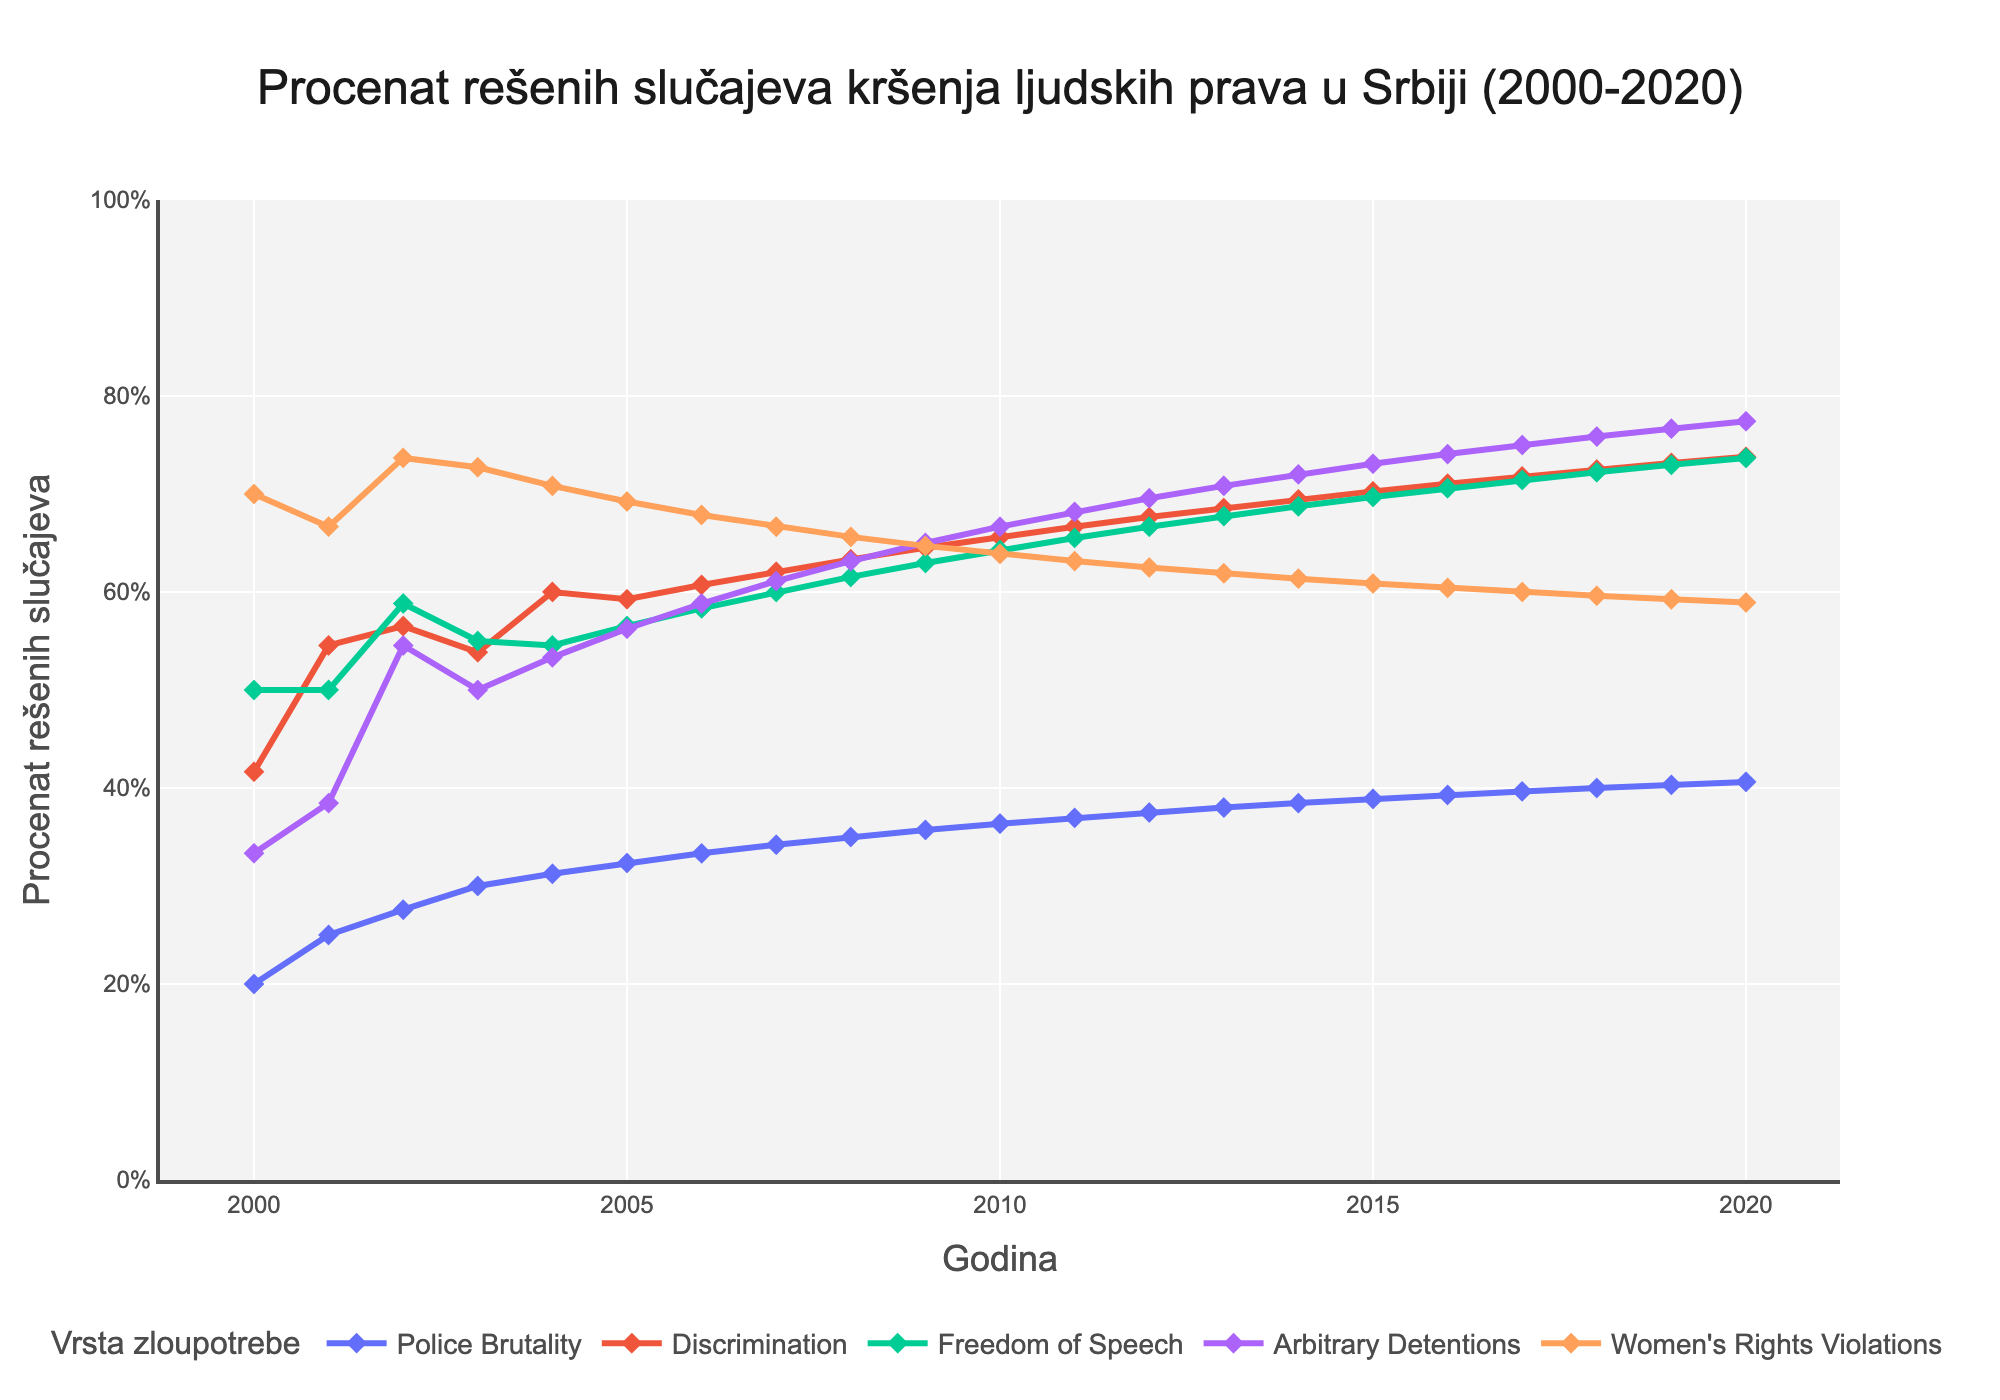What's the title of the figure? The title is displayed at the top of the figure. It summarizes the main subject of the plot, which is about the resolved cases of human rights abuses in Serbia over the given time period.
Answer: Procenat rešenih slučajeva kršenja ljudskih prava u Srbiji (2000-2020) What are the axes titles of the plot? The x-axis and y-axis titles can be found near the respective axes. The x-axis represents the "Year," while the y-axis represents the "Percentage of Resolved Cases."
Answer: Godina, Procenat rešenih slučajeva Which type of abuse had the highest percentage of resolved cases in 2000? To find this, look at the year 2000 on the x-axis and compare the y-values (percentage of resolved cases) for all types of abuses. The highest value indicates the type with the most resolved cases.
Answer: Women's Rights Violations How did the percentage of resolved Police Brutality cases change from 2000 to 2020? Locate the line corresponding to Police Brutality and observe its trend from the year 2000 to 2020. The percentage starts from around 20% and gradually increases to about 40% by 2020.
Answer: Increased Which year had the highest overall percentage of resolved cases across all types of abuses? To determine this, identify the peak points on the y-axis for all types of abuses collectively. The year representing the highest y-value will have the highest overall resolution.
Answer: 2020 Compare the trend lines of Police Brutality and Women's Rights Violations. Which one shows more improvement over the years? Analyze the slopes of both trend lines. A steeper upward trend would indicate more significant improvement. Police Brutality has a steady but smaller increase compared to Women's Rights Violations, which shows a more rapid rise.
Answer: Women's Rights Violations What is the average percentage of resolved Discrimination cases between 2000 and 2020? Add the percentage of resolved Discrimination cases for each year and then divide by the number of years (21). The values are 41.67%, 54.55%, 56.52%, 53.85%, 60%, 59.26%, 60.71%, 63.33%, 63.33%, 65.62%, 66.67%, 67.65%, 68.57%, 69.44%, 70.27%, 71.05%, 71.79%, 72.5%, 73.17%, 73.81%, and 74.29%. Sum these percentages: 1369.53, and divide by 21.
Answer: 65.22% Between Freedom of Speech and Arbitrary Detentions, which type of abuse had a higher percentage of resolved cases in 2010? Refer to the year 2010 on the x-axis and compare the y-values of both types of abuses. The higher value will indicate the type with the higher percentage of resolved cases.
Answer: Freedom of Speech Which type of abuse consistently had the lowest percentage of resolved cases over the 20-year period? Scan all the trend lines to identify which one is generally lowest across most of the years. Arbitrary Detentions has consistently lower values compared to the other abuses.
Answer: Arbitrary Detentions In which year did Women's Rights Violations reach a 100% resolution rate, and is it the only type of abuse to reach this rate? Observe the trend lines for Women's Rights Violations and find when it hits 100%. Also, check if any other type reaches 100%. The year is visible near 2007 for Women's Rights Violations, and no other type of abuse reaches 100%.
Answer: 2007, yes 